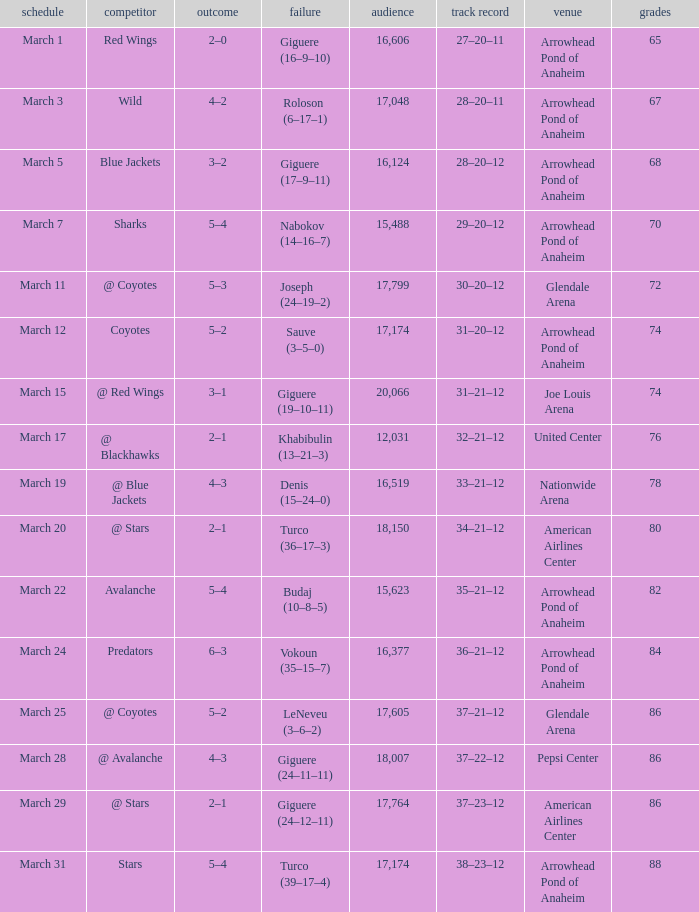What is the Attendance of the game with a Record of 37–21–12 and less than 86 Points? None. Write the full table. {'header': ['schedule', 'competitor', 'outcome', 'failure', 'audience', 'track record', 'venue', 'grades'], 'rows': [['March 1', 'Red Wings', '2–0', 'Giguere (16–9–10)', '16,606', '27–20–11', 'Arrowhead Pond of Anaheim', '65'], ['March 3', 'Wild', '4–2', 'Roloson (6–17–1)', '17,048', '28–20–11', 'Arrowhead Pond of Anaheim', '67'], ['March 5', 'Blue Jackets', '3–2', 'Giguere (17–9–11)', '16,124', '28–20–12', 'Arrowhead Pond of Anaheim', '68'], ['March 7', 'Sharks', '5–4', 'Nabokov (14–16–7)', '15,488', '29–20–12', 'Arrowhead Pond of Anaheim', '70'], ['March 11', '@ Coyotes', '5–3', 'Joseph (24–19–2)', '17,799', '30–20–12', 'Glendale Arena', '72'], ['March 12', 'Coyotes', '5–2', 'Sauve (3–5–0)', '17,174', '31–20–12', 'Arrowhead Pond of Anaheim', '74'], ['March 15', '@ Red Wings', '3–1', 'Giguere (19–10–11)', '20,066', '31–21–12', 'Joe Louis Arena', '74'], ['March 17', '@ Blackhawks', '2–1', 'Khabibulin (13–21–3)', '12,031', '32–21–12', 'United Center', '76'], ['March 19', '@ Blue Jackets', '4–3', 'Denis (15–24–0)', '16,519', '33–21–12', 'Nationwide Arena', '78'], ['March 20', '@ Stars', '2–1', 'Turco (36–17–3)', '18,150', '34–21–12', 'American Airlines Center', '80'], ['March 22', 'Avalanche', '5–4', 'Budaj (10–8–5)', '15,623', '35–21–12', 'Arrowhead Pond of Anaheim', '82'], ['March 24', 'Predators', '6–3', 'Vokoun (35–15–7)', '16,377', '36–21–12', 'Arrowhead Pond of Anaheim', '84'], ['March 25', '@ Coyotes', '5–2', 'LeNeveu (3–6–2)', '17,605', '37–21–12', 'Glendale Arena', '86'], ['March 28', '@ Avalanche', '4–3', 'Giguere (24–11–11)', '18,007', '37–22–12', 'Pepsi Center', '86'], ['March 29', '@ Stars', '2–1', 'Giguere (24–12–11)', '17,764', '37–23–12', 'American Airlines Center', '86'], ['March 31', 'Stars', '5–4', 'Turco (39–17–4)', '17,174', '38–23–12', 'Arrowhead Pond of Anaheim', '88']]} 